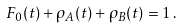<formula> <loc_0><loc_0><loc_500><loc_500>F _ { 0 } ( t ) + \rho _ { A } ( t ) + \rho _ { B } ( t ) = 1 \, .</formula> 